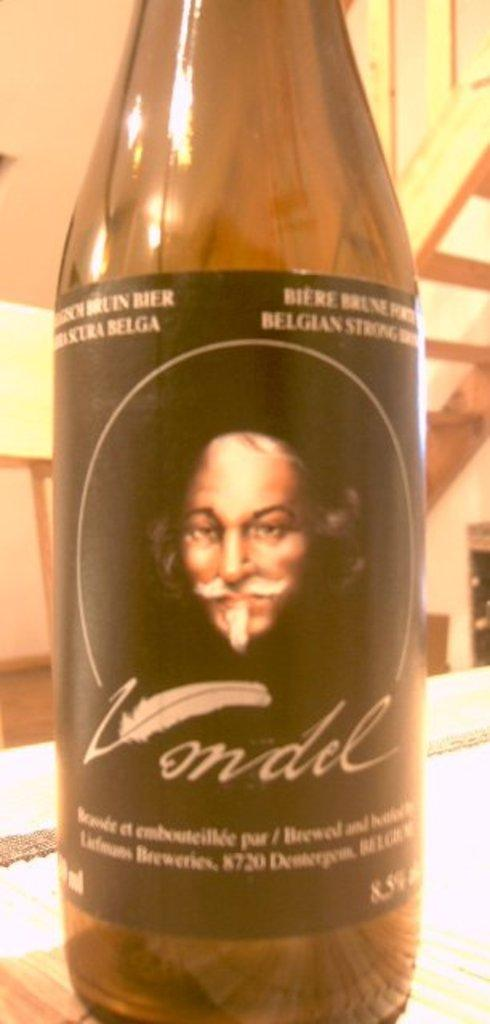Provide a one-sentence caption for the provided image. The Vondel wine bottle's label contains an image of an old, bald, mustached white man. 